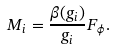Convert formula to latex. <formula><loc_0><loc_0><loc_500><loc_500>M _ { i } = \frac { \beta ( g _ { i } ) } { g _ { i } } F _ { \phi } .</formula> 